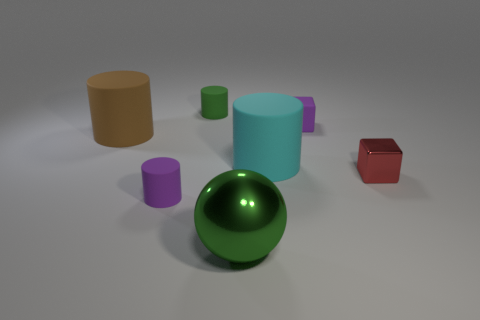Is there anything else that is the same shape as the large green object?
Offer a terse response. No. Are there fewer large brown metal blocks than big green metal things?
Offer a very short reply. Yes. There is a small metallic cube that is behind the large green object; what color is it?
Make the answer very short. Red. The large thing that is to the left of the tiny cylinder in front of the tiny shiny block is what shape?
Make the answer very short. Cylinder. Does the tiny purple cube have the same material as the large cylinder that is on the left side of the tiny green rubber cylinder?
Ensure brevity in your answer.  Yes. What shape is the matte object that is the same color as the rubber cube?
Ensure brevity in your answer.  Cylinder. How many brown things are the same size as the red cube?
Your answer should be very brief. 0. Are there fewer red metallic blocks in front of the big sphere than green cylinders?
Your answer should be very brief. Yes. What number of big cylinders are right of the large cyan thing?
Your response must be concise. 0. What is the size of the rubber cylinder behind the tiny cube that is left of the small red metal block that is on the right side of the ball?
Ensure brevity in your answer.  Small. 